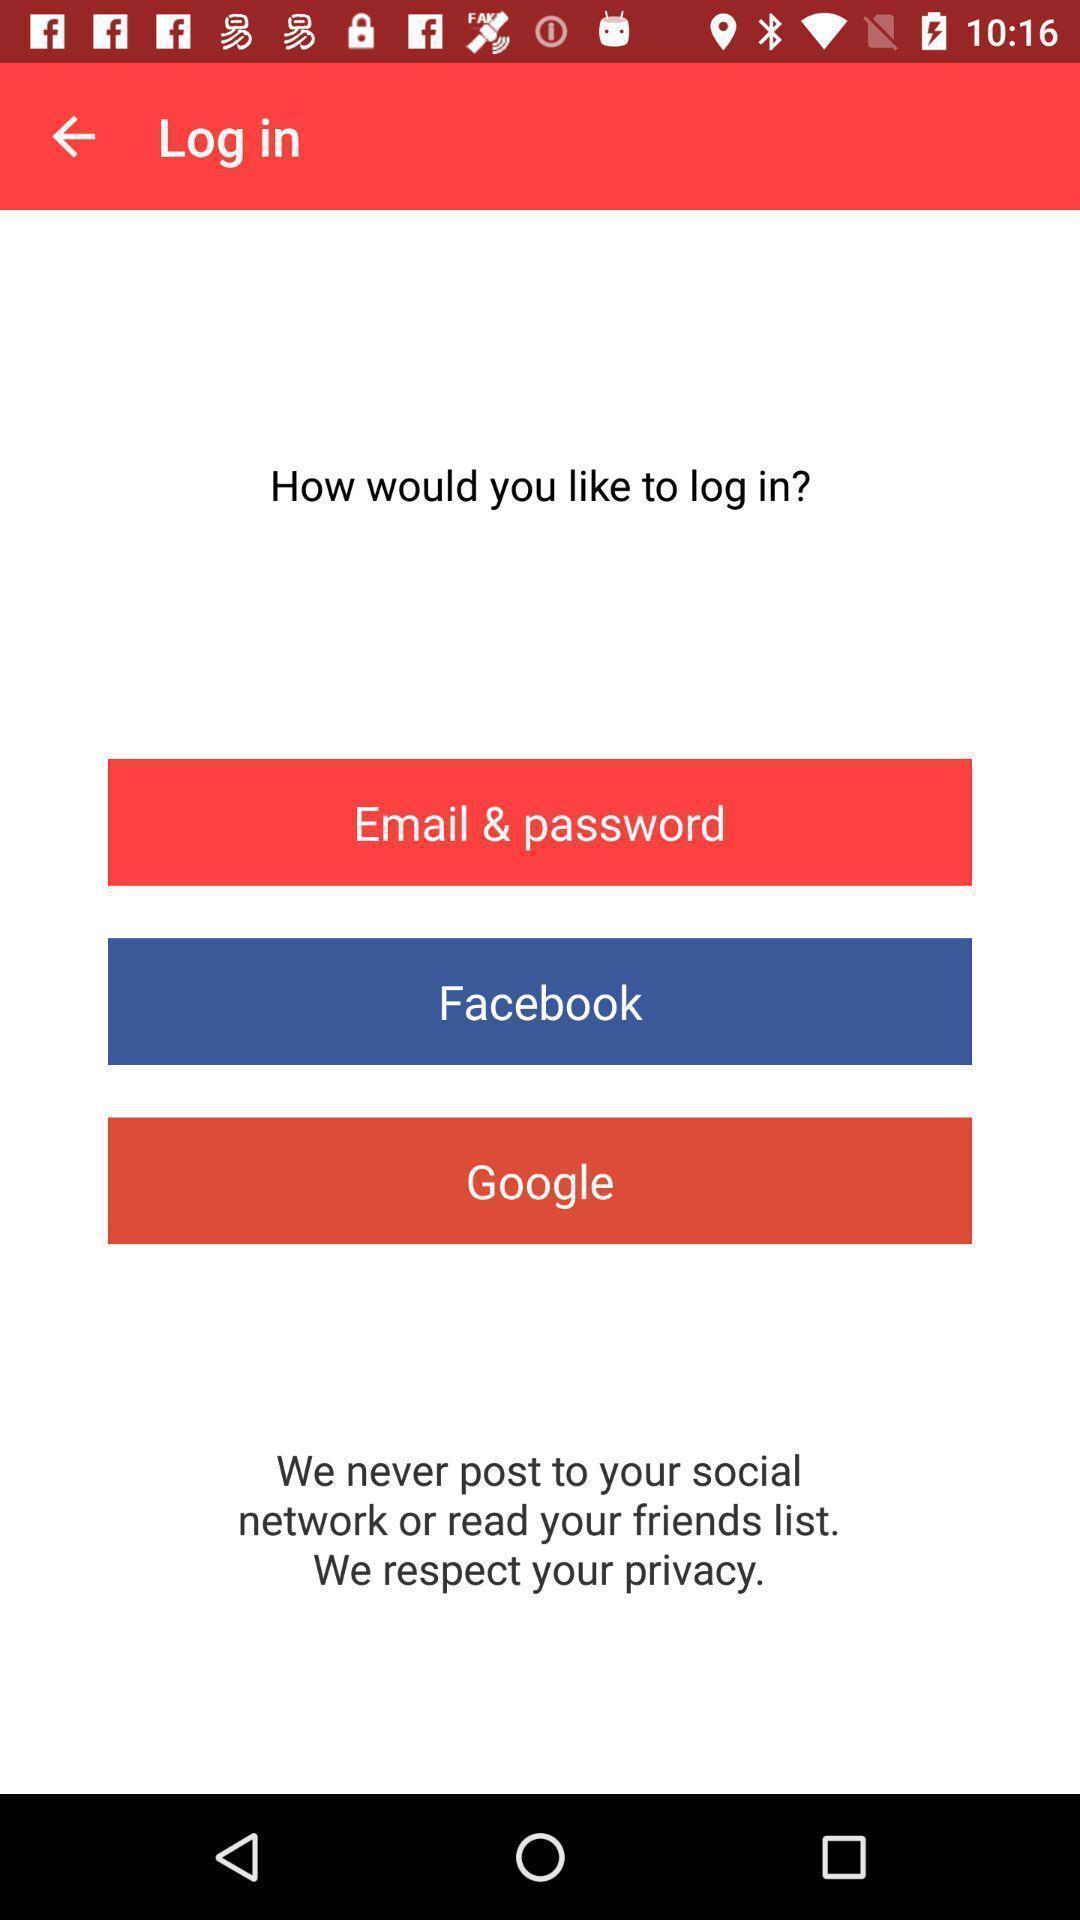Provide a detailed account of this screenshot. Screen showing how would you like to log in. 